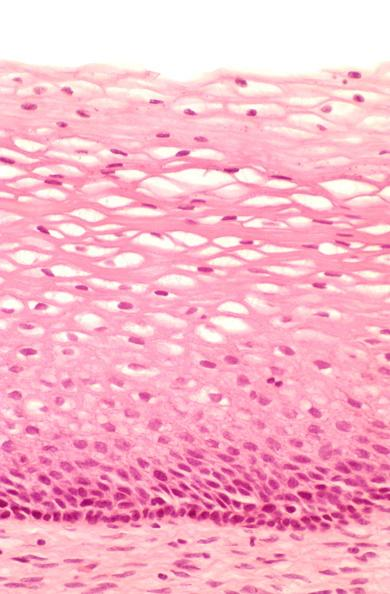does this image show cervix, mild dysplasia?
Answer the question using a single word or phrase. Yes 